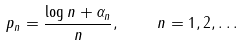Convert formula to latex. <formula><loc_0><loc_0><loc_500><loc_500>p _ { n } = \frac { \log n + \alpha _ { n } } { n } , \quad n = 1 , 2 , \dots</formula> 